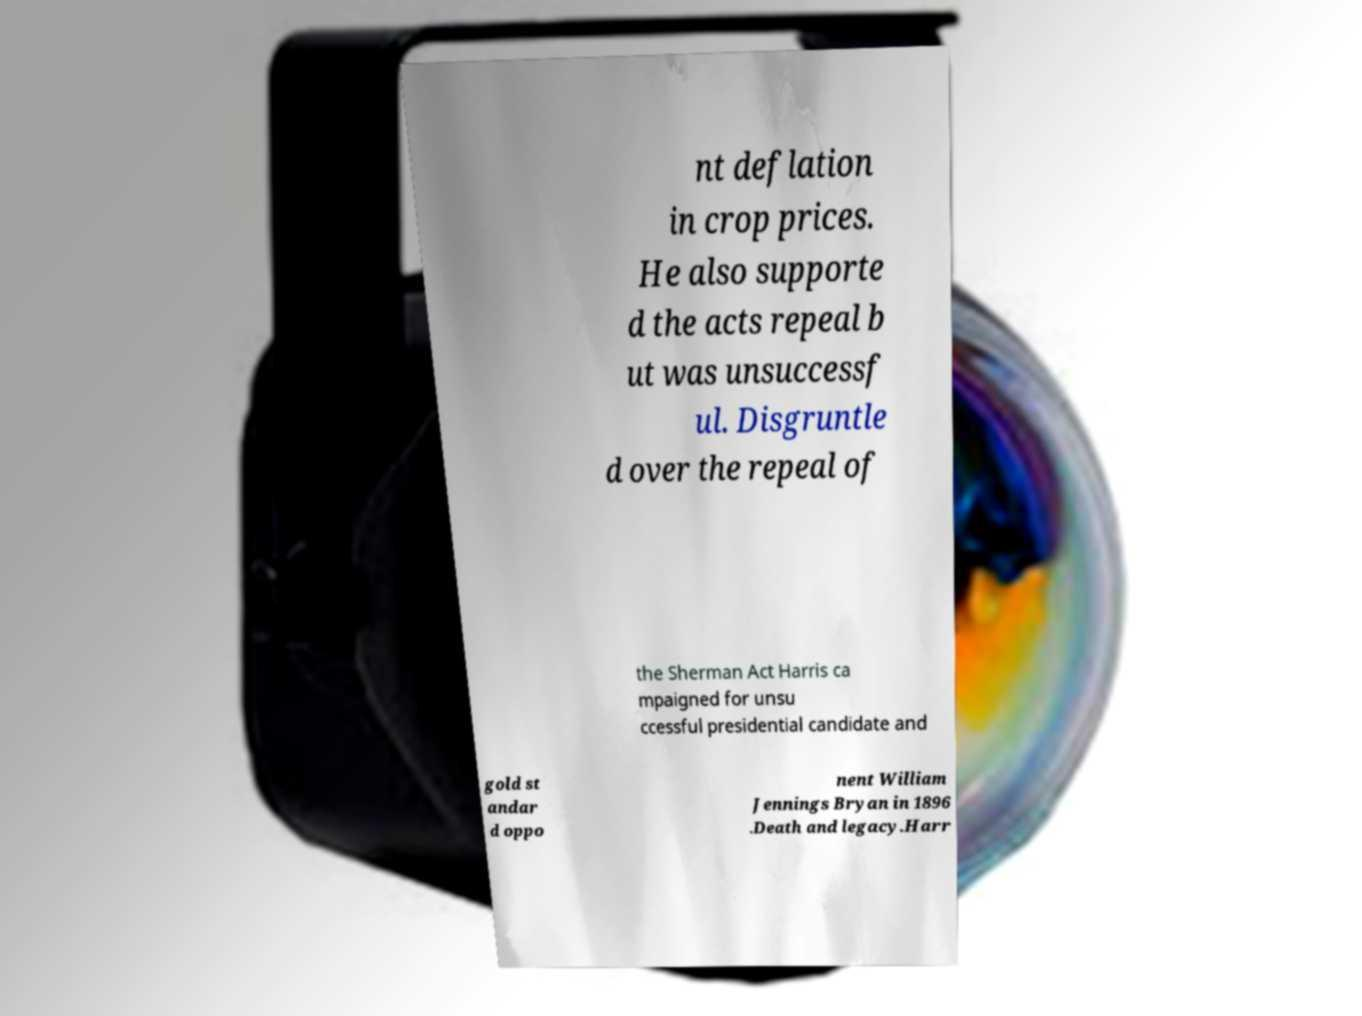For documentation purposes, I need the text within this image transcribed. Could you provide that? nt deflation in crop prices. He also supporte d the acts repeal b ut was unsuccessf ul. Disgruntle d over the repeal of the Sherman Act Harris ca mpaigned for unsu ccessful presidential candidate and gold st andar d oppo nent William Jennings Bryan in 1896 .Death and legacy.Harr 